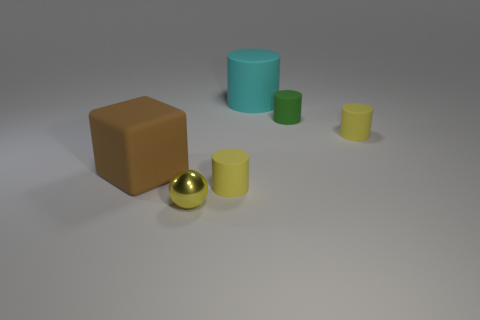Subtract all gray cylinders. Subtract all green balls. How many cylinders are left? 4 Add 2 large cyan rubber cubes. How many objects exist? 8 Subtract all cubes. How many objects are left? 5 Add 5 big cyan rubber cylinders. How many big cyan rubber cylinders are left? 6 Add 2 brown matte blocks. How many brown matte blocks exist? 3 Subtract 0 red cylinders. How many objects are left? 6 Subtract all tiny yellow shiny cylinders. Subtract all cyan cylinders. How many objects are left? 5 